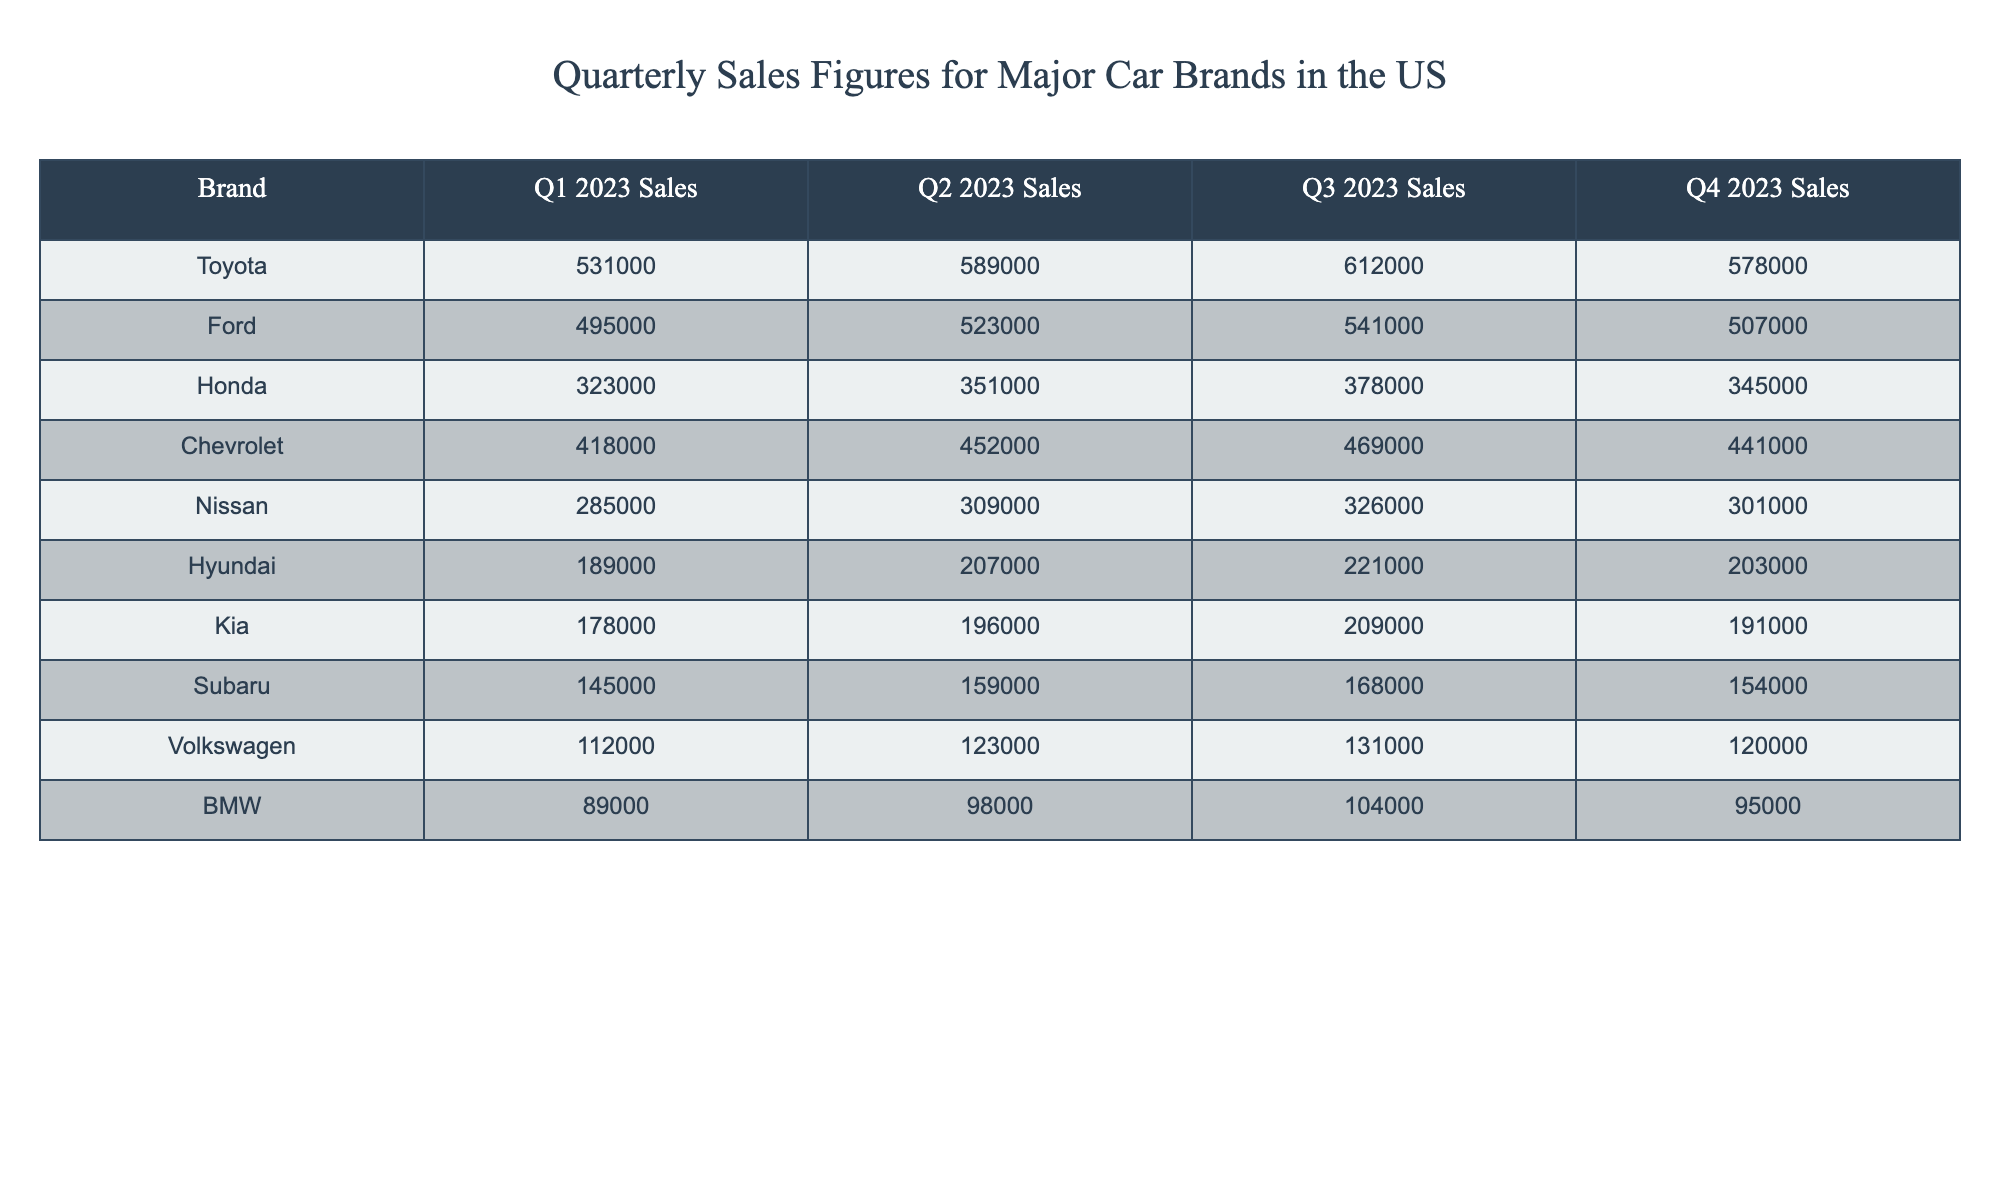What was Toyota's sales figure in Q2 2023? The table shows that Toyota's sales in Q2 2023 were 589,000 units.
Answer: 589,000 Which brand sold the least cars in Q4 2023? In Q4 2023, Volkswagen had the lowest sales figure listed, totaling 120,000 units.
Answer: Volkswagen What is the sum of Ford's sales across all quarters? Ford's sales are 495,000 (Q1) + 523,000 (Q2) + 541,000 (Q3) + 507,000 (Q4) = 2,066,000 units.
Answer: 2,066,000 Did Nissan's sales increase every quarter? Nissan's sales figures show a pattern of increase in Q1 (285,000), Q2 (309,000), and Q3 (326,000), but a decrease in Q4 to 301,000, indicating not every quarter saw an increase.
Answer: No What was the average quarterly sales figure for Honda in 2023? Honda's quarterly sales figures are 323,000 (Q1), 351,000 (Q2), 378,000 (Q3), and 345,000 (Q4), summing to 1,397,000. Dividing by 4 gives an average of 349,250 units.
Answer: 349,250 Which brand had more sales in Q3 compared to Q2? Looking at the sales figures, Toyota (612,000) and Honda (378,000) had higher sales in Q3 compared to their Q2 figures (589,000 for Toyota and 351,000 for Honda).
Answer: Toyota and Honda What is the difference in sales between Chevrolet and Hyundai in Q1 2023? Chevrolet's Q1 sales were 418,000 while Hyundai's were 189,000. The difference is 418,000 - 189,000 = 229,000 units.
Answer: 229,000 Which brand had consistent sales across all quarters? When examining the sales figures, Kia has similar sales close to each other over the quarters, showing minimal fluctuation (178,000 to 209,000).
Answer: Kia What percentage of Toyota's Q1 sales is represented by BMW's Q1 sales? Toyota sold 531,000 in Q1 and BMW 89,000. To find the percentage, divide BMW's sales by Toyota's sales (89,000 / 531,000) and multiply by 100, resulting in approximately 16.75%.
Answer: 16.75% Which brand saw the highest sales increase from Q1 to Q3? Comparing the figures, Honda increased from 323,000 in Q1 to 378,000 in Q3, an increase of 55,000. However, Toyota had an increase from 531,000 in Q1 to 612,000 in Q3, which is a higher increase of 81,000.
Answer: Toyota What is the total sales for all brands combined in Q4 2023? Summing the Q4 figures yields 578,000 (Toyota) + 507,000 (Ford) + 345,000 (Honda) + 441,000 (Chevrolet) + 301,000 (Nissan) + 203,000 (Hyundai) + 191,000 (Kia) + 154,000 (Subaru) + 120,000 (Volkswagen) + 95,000 (BMW) = 2,244,000 units.
Answer: 2,244,000 